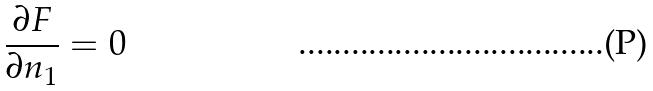Convert formula to latex. <formula><loc_0><loc_0><loc_500><loc_500>\frac { \partial F } { \partial n _ { 1 } } = 0</formula> 